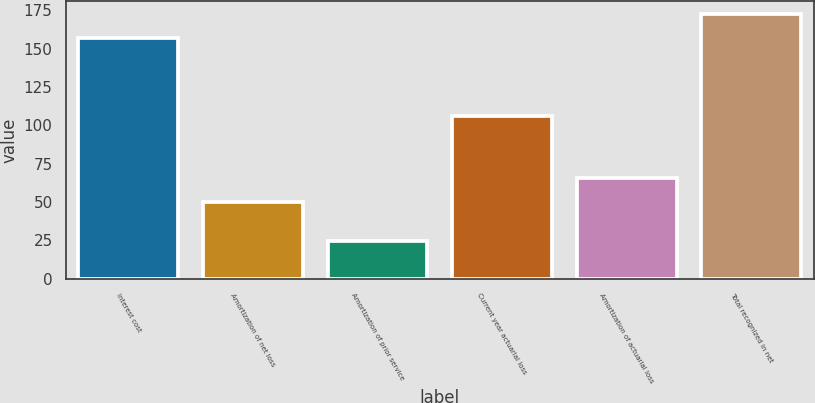Convert chart to OTSL. <chart><loc_0><loc_0><loc_500><loc_500><bar_chart><fcel>Interest cost<fcel>Amortization of net loss<fcel>Amortization of prior service<fcel>Current year actuarial loss<fcel>Amortization of actuarial loss<fcel>Total recognized in net<nl><fcel>157<fcel>50<fcel>24.5<fcel>106<fcel>65.5<fcel>172.5<nl></chart> 